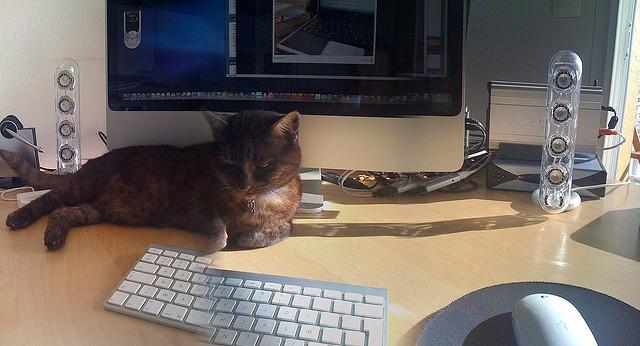Is the sunlight shining on the cat?
Answer briefly. Yes. What is the table made out of?
Be succinct. Wood. Where is the kitten in this photo?
Be succinct. On desk. Is it sunny?
Quick response, please. Yes. 